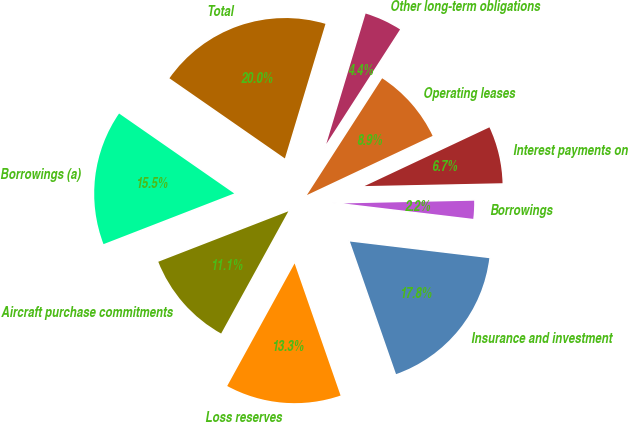<chart> <loc_0><loc_0><loc_500><loc_500><pie_chart><fcel>Loss reserves<fcel>Insurance and investment<fcel>Borrowings<fcel>Interest payments on<fcel>Operating leases<fcel>Other long-term obligations<fcel>Total<fcel>Borrowings (a)<fcel>Aircraft purchase commitments<nl><fcel>13.33%<fcel>17.78%<fcel>2.22%<fcel>6.67%<fcel>8.89%<fcel>4.45%<fcel>20.0%<fcel>15.55%<fcel>11.11%<nl></chart> 